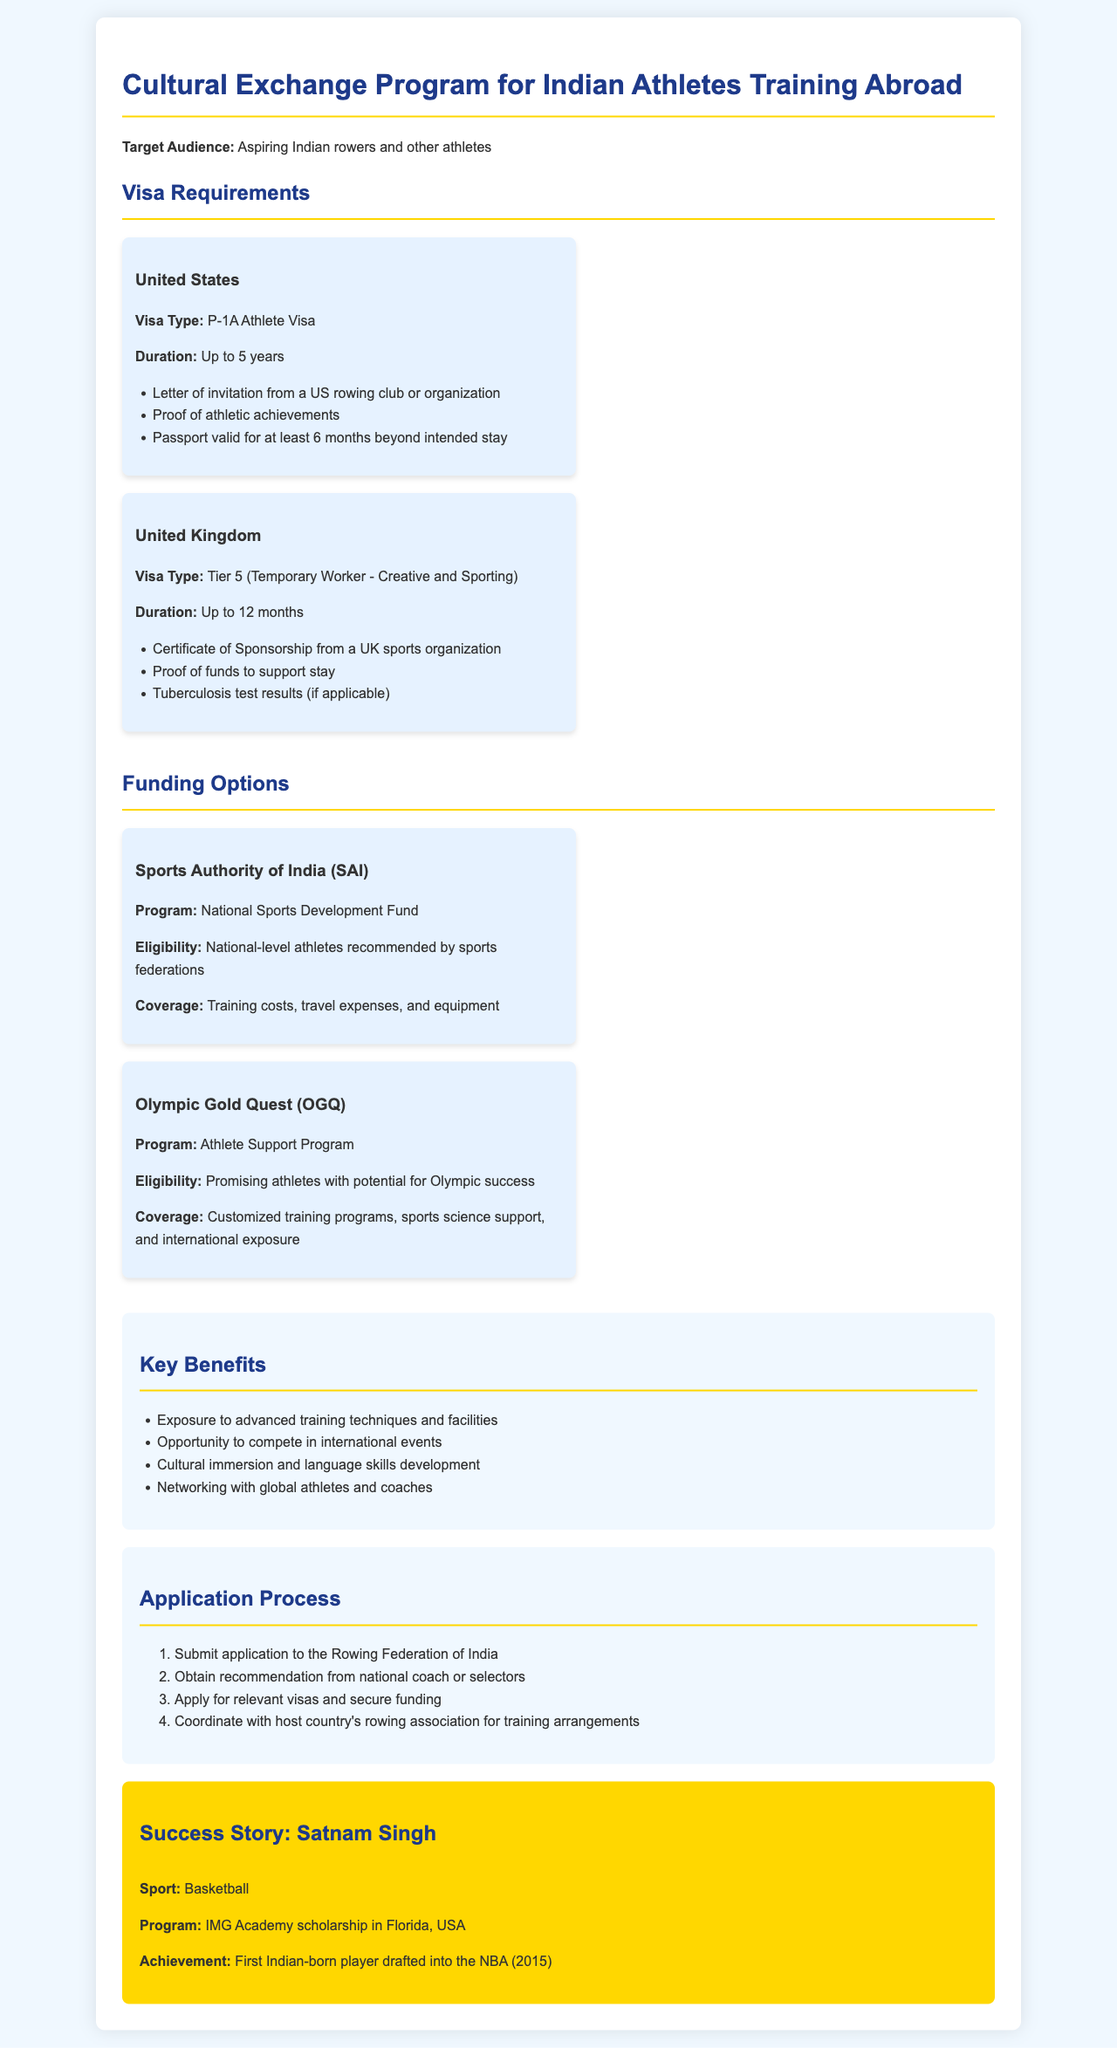What is the visa type required for the United States? The document specifies that the visa type is the P-1A Athlete Visa for the United States.
Answer: P-1A Athlete Visa How long can athletes stay in the United Kingdom on a Tier 5 visa? The document states that the duration of stay on a Tier 5 visa in the UK is up to 12 months.
Answer: Up to 12 months What organization provides funding through the National Sports Development Fund? The funding organization mentioned for the National Sports Development Fund is the Sports Authority of India (SAI).
Answer: Sports Authority of India (SAI) Which athlete was the first Indian-born player drafted into the NBA? The document highlights that Satnam Singh was the first Indian-born player drafted into the NBA.
Answer: Satnam Singh What is the eligibility requirement for the Olympic Gold Quest funding? According to the document, the eligibility for the Olympic Gold Quest funding is promising athletes with potential for Olympic success.
Answer: Promising athletes with potential for Olympic success What are athletes advised to do first in the application process? The document outlines that the first step in the application process is to submit an application to the Rowing Federation of India.
Answer: Submit application to the Rowing Federation of India List one key benefit of the cultural exchange program. One key benefit mentioned in the document is exposure to advanced training techniques and facilities.
Answer: Exposure to advanced training techniques and facilities What is required for a visa application to the United States? The document states that a letter of invitation from a US rowing club or organization is required for a visa application to the United States.
Answer: Letter of invitation from a US rowing club or organization 